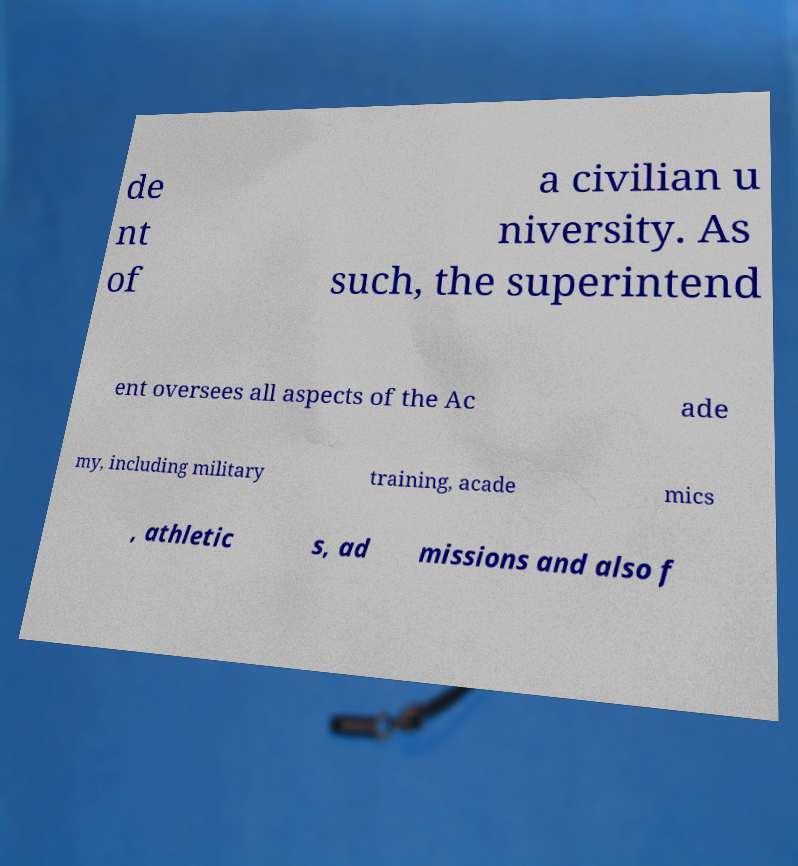I need the written content from this picture converted into text. Can you do that? de nt of a civilian u niversity. As such, the superintend ent oversees all aspects of the Ac ade my, including military training, acade mics , athletic s, ad missions and also f 